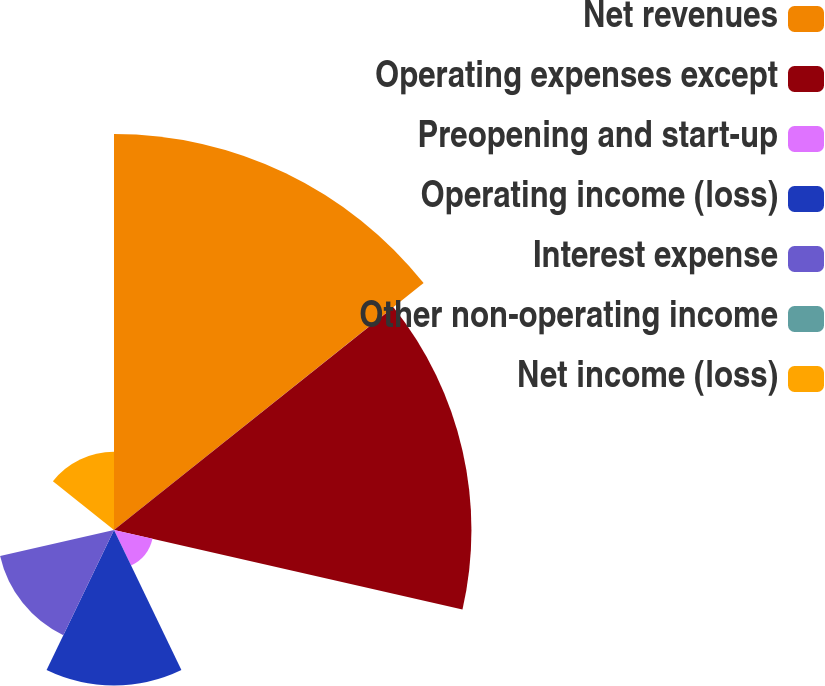<chart> <loc_0><loc_0><loc_500><loc_500><pie_chart><fcel>Net revenues<fcel>Operating expenses except<fcel>Preopening and start-up<fcel>Operating income (loss)<fcel>Interest expense<fcel>Other non-operating income<fcel>Net income (loss)<nl><fcel>34.61%<fcel>31.24%<fcel>3.45%<fcel>13.58%<fcel>10.21%<fcel>0.08%<fcel>6.83%<nl></chart> 